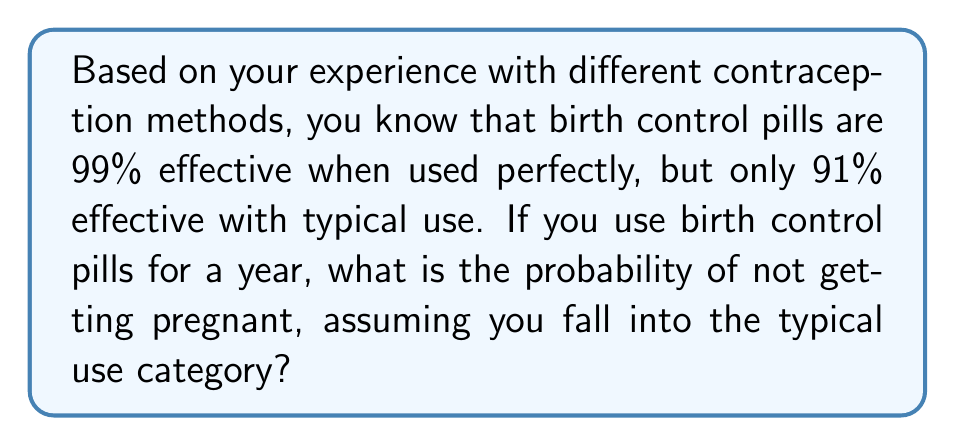Show me your answer to this math problem. Let's approach this step-by-step:

1) First, we need to understand what the effectiveness percentage means. A 91% effectiveness rate means that out of 100 women using this method for a year, 91 will not get pregnant.

2) To find the probability of not getting pregnant, we need to convert this percentage to a decimal:
   
   $91\% = 0.91$

3) Now, we need to consider that this is the probability for an entire year. In probability theory, when we want to find the probability of an event not occurring over multiple trials, we use the following formula:

   $P(\text{no occurrence}) = (1 - p)^n$

   Where $p$ is the probability of the event occurring in a single trial, and $n$ is the number of trials.

4) In our case, $p$ is the probability of getting pregnant in a year, which is $1 - 0.91 = 0.09$

5) We only have one "trial" (one year), so $n = 1$

6) Plugging these values into our formula:

   $P(\text{not pregnant}) = (1 - 0.09)^1 = 0.91$

Therefore, the probability of not getting pregnant over the course of a year, using birth control pills with typical use, is 0.91 or 91%.
Answer: 0.91 